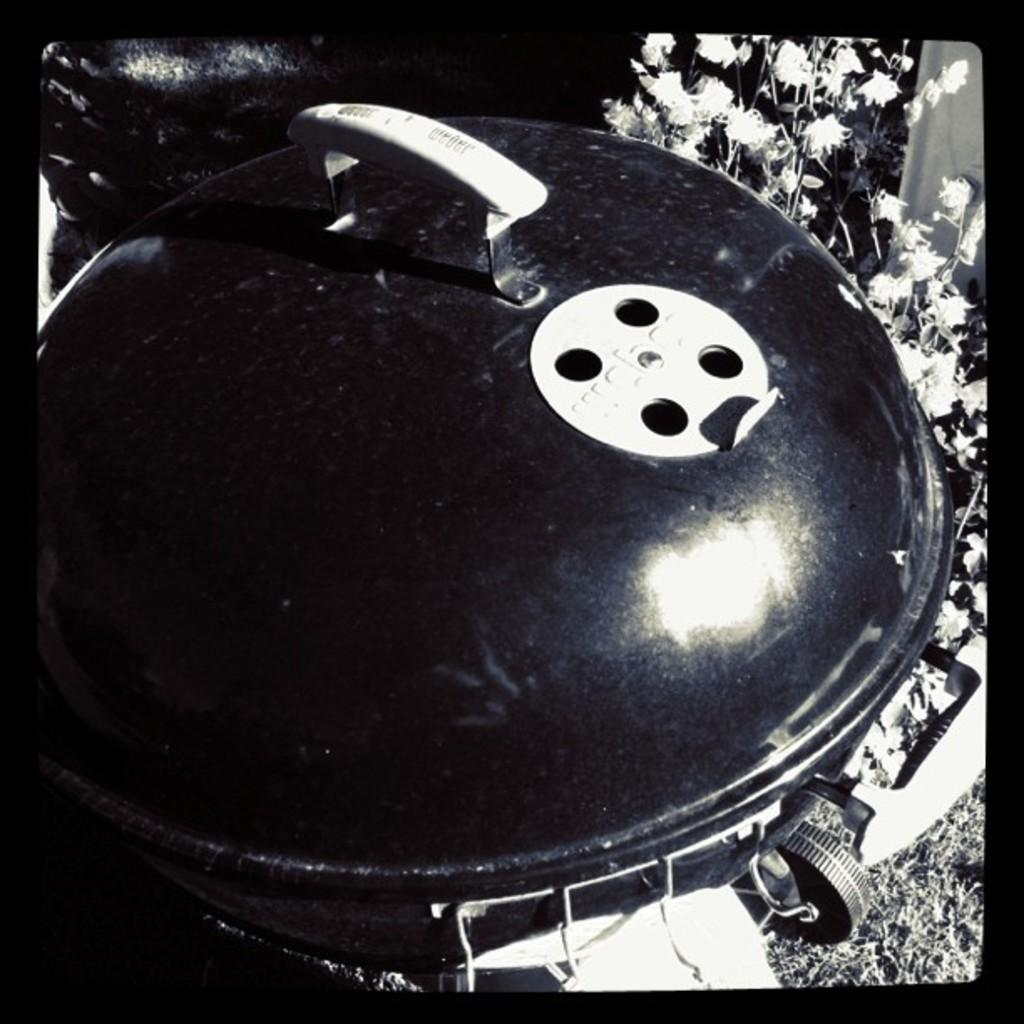What is the main object in the middle of the image? There is a dustbin in the middle of the image. What can be seen behind the dustbin? There are flowers behind the dustbin. What type of vegetation is visible in the image? There is grass visible in the image. What type of fang can be seen in the image? There is no fang present in the image. How many pins are visible in the image? There is no mention of pins in the provided facts, so we cannot determine if any are visible in the image. 